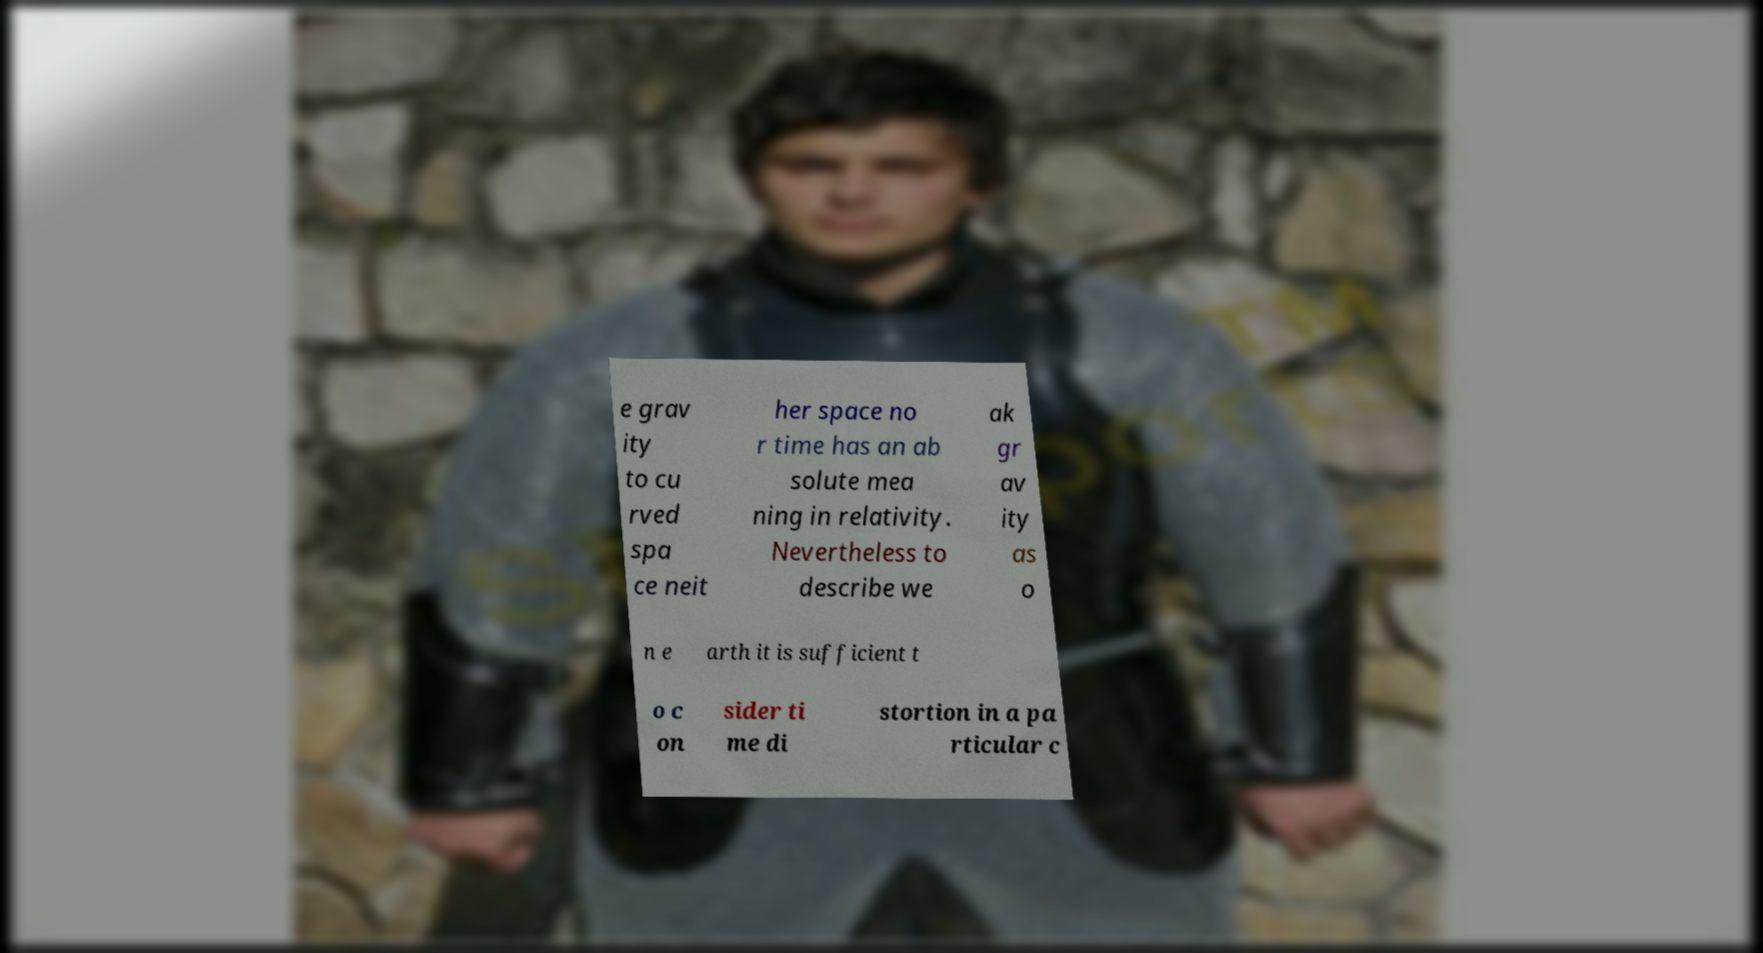Could you extract and type out the text from this image? e grav ity to cu rved spa ce neit her space no r time has an ab solute mea ning in relativity. Nevertheless to describe we ak gr av ity as o n e arth it is sufficient t o c on sider ti me di stortion in a pa rticular c 